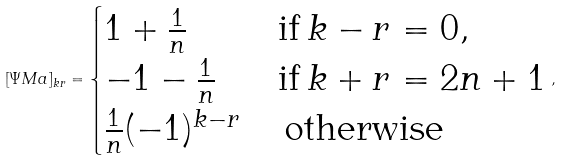Convert formula to latex. <formula><loc_0><loc_0><loc_500><loc_500>[ \Psi M a ] _ { k r } = \begin{cases} 1 + \frac { 1 } { n } & \text {if} \, k - r = 0 , \\ - 1 - \frac { 1 } { n } & \text {if} \, k + r = 2 n + 1 \\ \frac { 1 } { n } ( - 1 ) ^ { k - r } & \, \text {otherwise} \end{cases} ,</formula> 